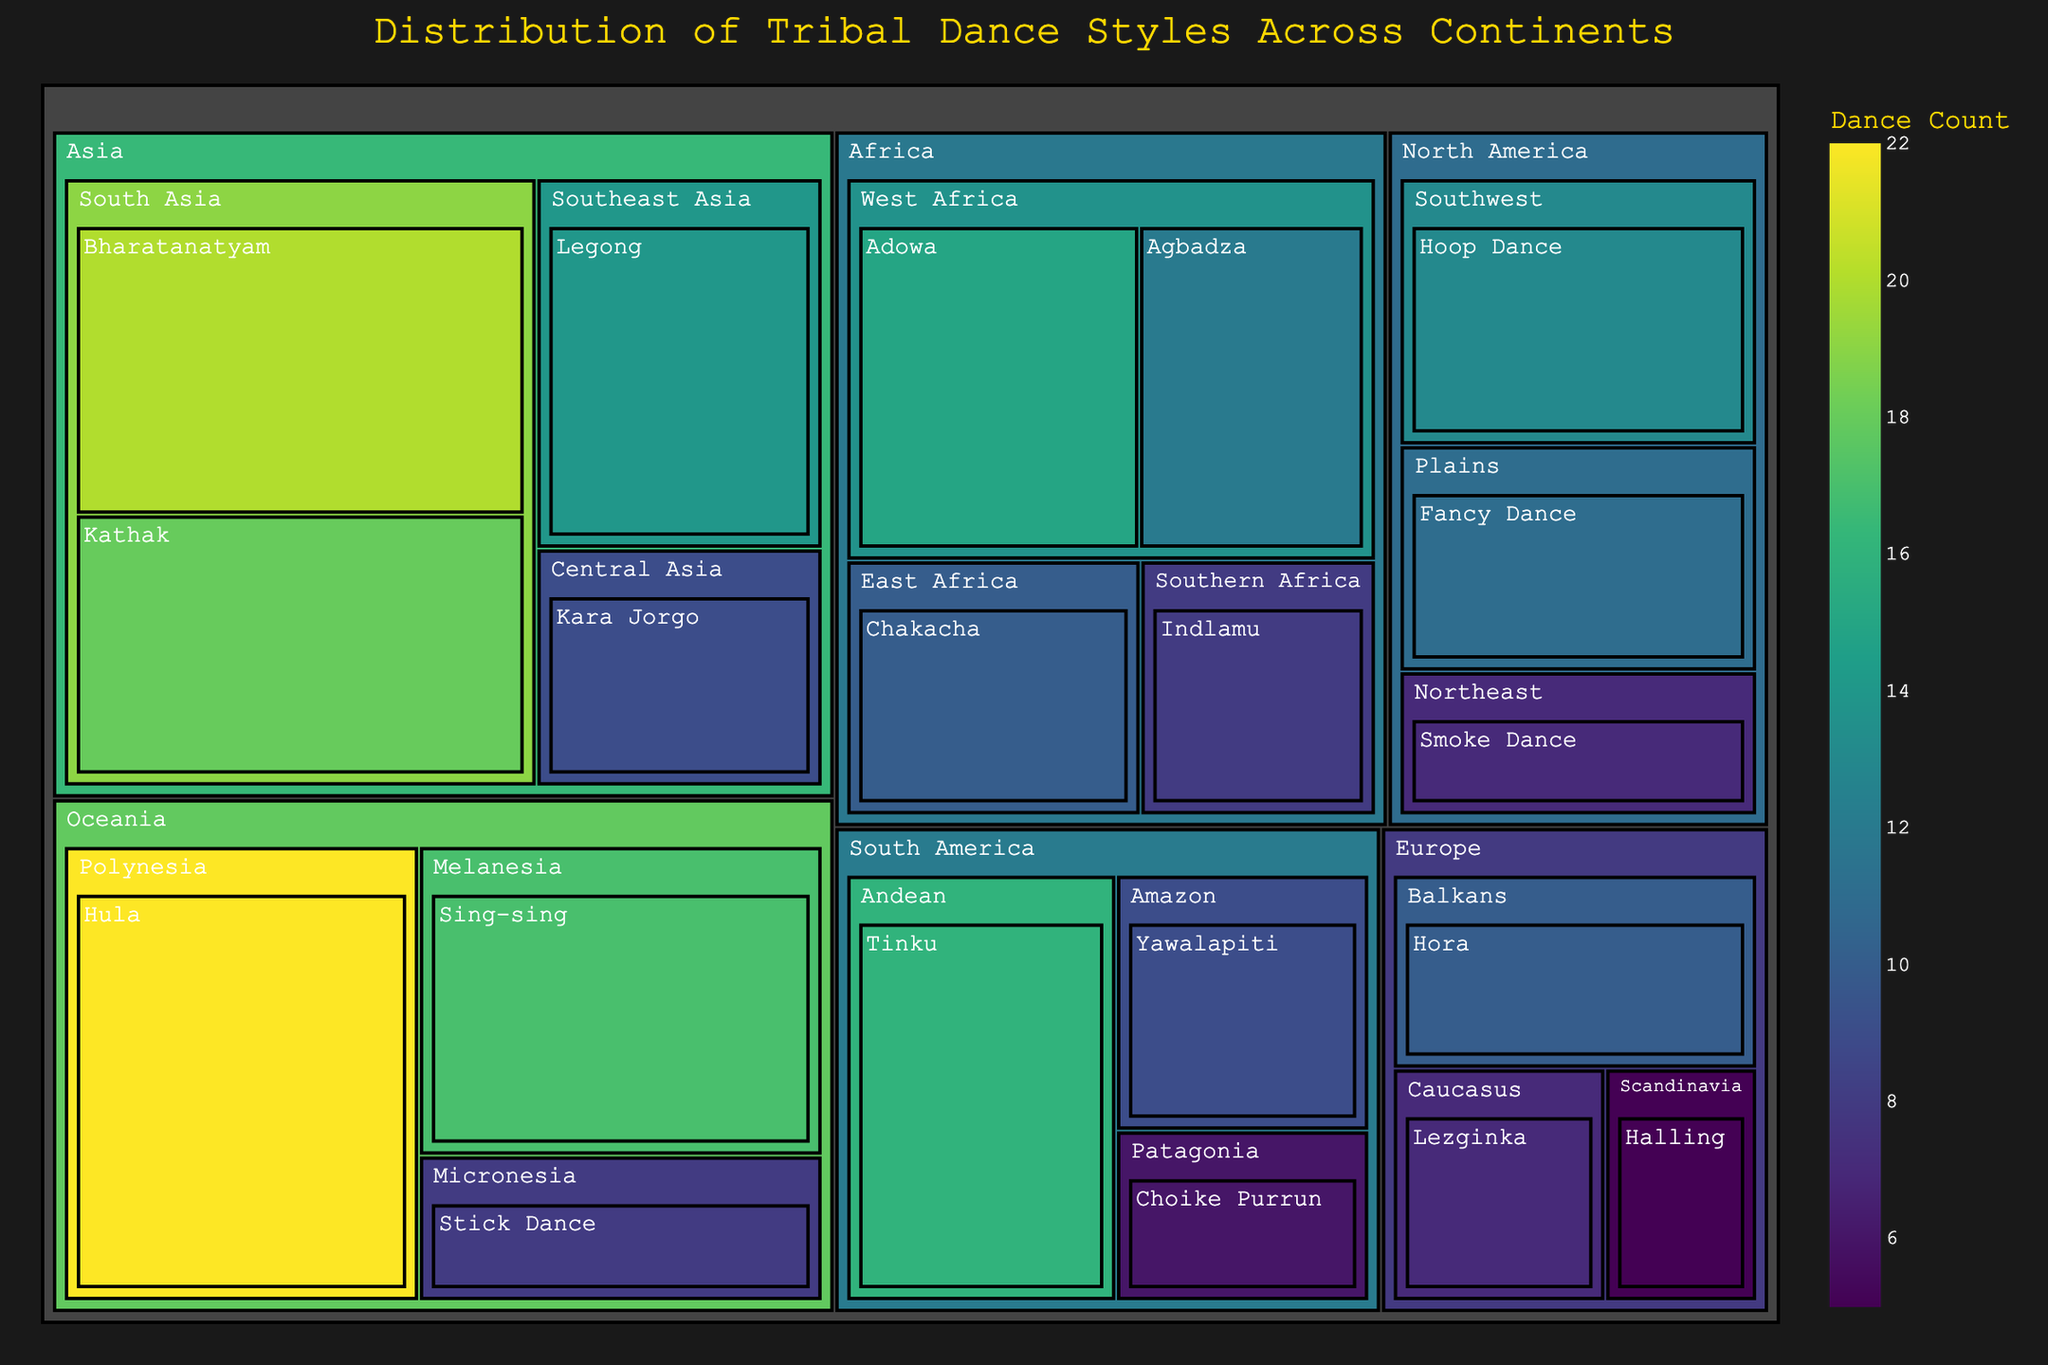What is the title of the plot? The title can be found at the top of the visual representation, usually in a larger font and different color.
Answer: Distribution of Tribal Dance Styles Across Continents How many dance styles are represented in Africa? To answer this, count the distinct dance style names under the "Africa" section in the treemap. There are four dance styles: Adowa, Agbadza, Chakacha, and Indlamu.
Answer: 4 Which region in Oceania has the most distinct dance styles? Locate the Oceania section and see the subregions under it. Compare the counts of dance styles in Polynesia, Melanesia, and Micronesia.
Answer: Polynesia What dance count does the dance style with the second-highest count in South America have? Identify the dance styles in South America, then compare their counts and find the second highest. Tinku has 16, Yawalapiti has 9, and Choike Purrun has 6.
Answer: 9 Between Kathak and Legong, which dance style has more counts? Compare the counts associated with Kathak (18) and Legong (14) from the Asia section.
Answer: Kathak Which continent has the dance with the highest count, and what is that count? Identify the dance styles with the highest numbers and check which continent they belong to. Hula in Oceania has the highest count of 22.
Answer: Oceania, 22 Calculate the total number of distinct dances in North America. Sum the counts of all dance styles in the North America section. Fancy Dance (11), Hoop Dance (13), and Smoke Dance (7). 11 + 13 + 7 = 31
Answer: 31 How many continents have dance styles with counts over 20? Check each continent's dance styles and see which have counts over 20. Bharatanatyam from Asia and Hula from Oceania meet this criteria.
Answer: 2 What is the most common color range represented in the treemap? Look at the color scheme for the treemap to identify the most frequently appearing color range, which indicates a majority value count.
Answer: A shade of green Which continent has the least representation of distinct dance styles? Count the total number of distinct dance styles in each continent and identify the one with the least. Europe has 3 styles: Hora, Lezginka, and Halling.
Answer: Europe 